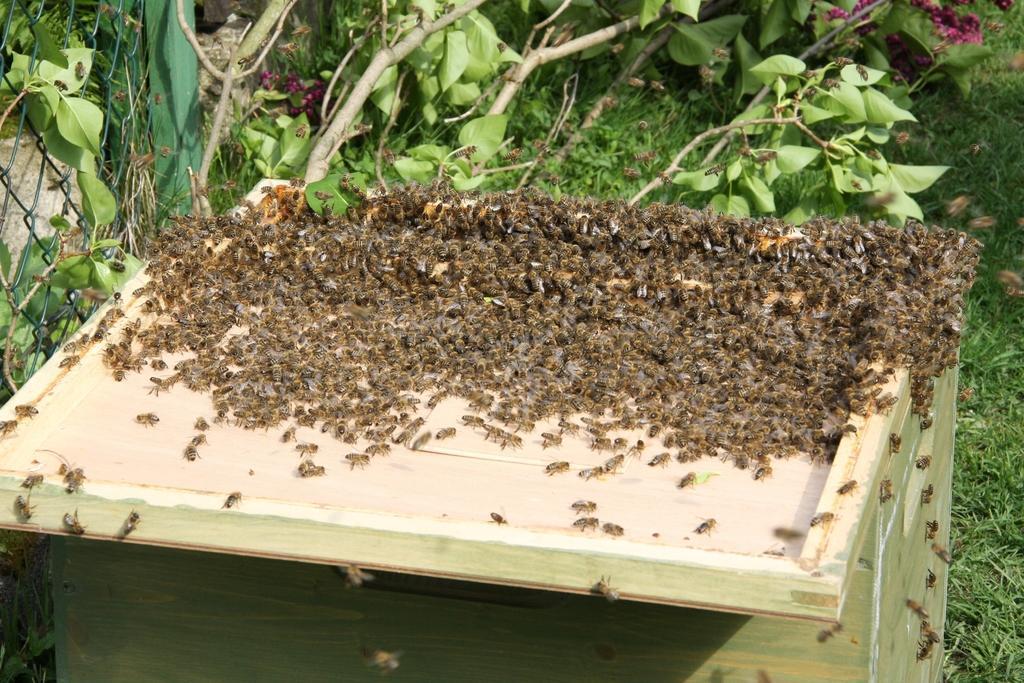How would you summarize this image in a sentence or two? In the picture I can see many honey bees on the wooden table. In the background, I can see the fence, grass and trees. 